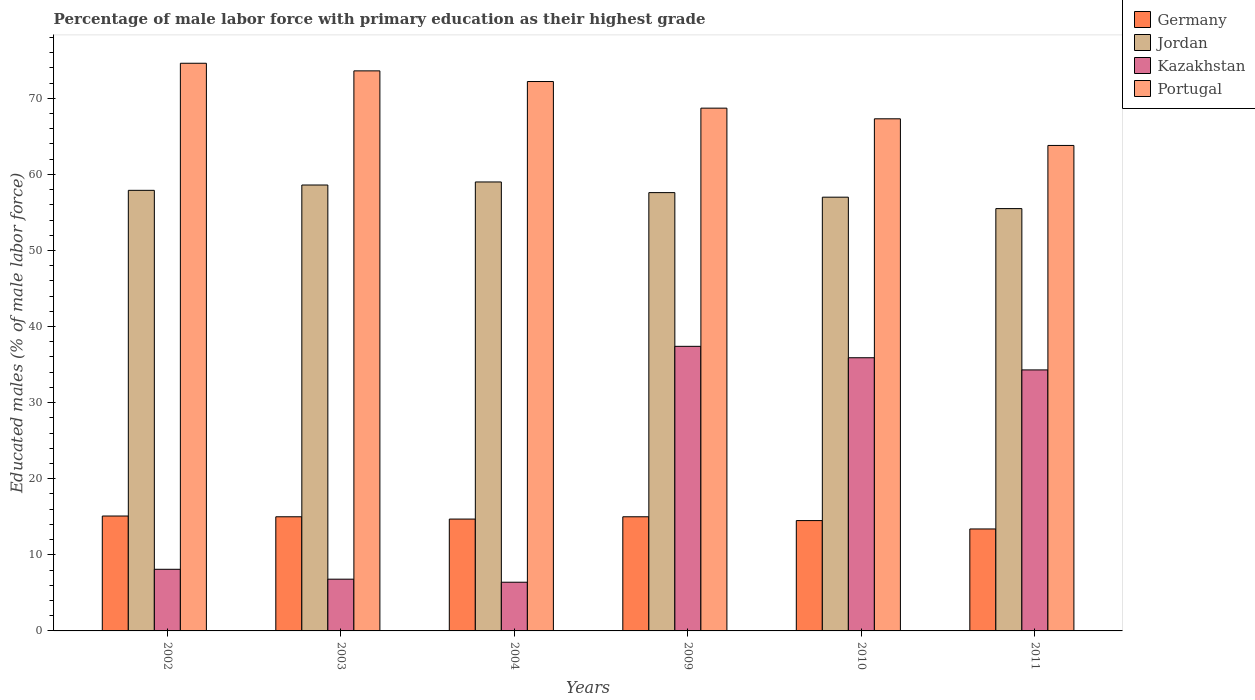How many different coloured bars are there?
Keep it short and to the point. 4. How many groups of bars are there?
Offer a very short reply. 6. Are the number of bars per tick equal to the number of legend labels?
Offer a very short reply. Yes. Are the number of bars on each tick of the X-axis equal?
Your answer should be compact. Yes. What is the label of the 5th group of bars from the left?
Provide a short and direct response. 2010. What is the percentage of male labor force with primary education in Germany in 2003?
Give a very brief answer. 15. Across all years, what is the maximum percentage of male labor force with primary education in Portugal?
Offer a very short reply. 74.6. Across all years, what is the minimum percentage of male labor force with primary education in Germany?
Provide a succinct answer. 13.4. In which year was the percentage of male labor force with primary education in Germany minimum?
Give a very brief answer. 2011. What is the total percentage of male labor force with primary education in Portugal in the graph?
Offer a very short reply. 420.2. What is the difference between the percentage of male labor force with primary education in Jordan in 2011 and the percentage of male labor force with primary education in Kazakhstan in 2009?
Offer a very short reply. 18.1. What is the average percentage of male labor force with primary education in Kazakhstan per year?
Provide a short and direct response. 21.48. In the year 2009, what is the difference between the percentage of male labor force with primary education in Jordan and percentage of male labor force with primary education in Portugal?
Keep it short and to the point. -11.1. In how many years, is the percentage of male labor force with primary education in Germany greater than 34 %?
Keep it short and to the point. 0. What is the ratio of the percentage of male labor force with primary education in Germany in 2003 to that in 2011?
Provide a succinct answer. 1.12. Is the percentage of male labor force with primary education in Jordan in 2003 less than that in 2009?
Provide a short and direct response. No. What is the difference between the highest and the second highest percentage of male labor force with primary education in Portugal?
Keep it short and to the point. 1. What is the difference between the highest and the lowest percentage of male labor force with primary education in Portugal?
Your answer should be compact. 10.8. In how many years, is the percentage of male labor force with primary education in Portugal greater than the average percentage of male labor force with primary education in Portugal taken over all years?
Offer a terse response. 3. What does the 2nd bar from the left in 2011 represents?
Offer a very short reply. Jordan. What does the 2nd bar from the right in 2009 represents?
Your response must be concise. Kazakhstan. Is it the case that in every year, the sum of the percentage of male labor force with primary education in Jordan and percentage of male labor force with primary education in Germany is greater than the percentage of male labor force with primary education in Kazakhstan?
Make the answer very short. Yes. How many bars are there?
Your response must be concise. 24. Are all the bars in the graph horizontal?
Provide a succinct answer. No. Does the graph contain grids?
Your response must be concise. No. How many legend labels are there?
Your response must be concise. 4. How are the legend labels stacked?
Your response must be concise. Vertical. What is the title of the graph?
Provide a succinct answer. Percentage of male labor force with primary education as their highest grade. Does "Mali" appear as one of the legend labels in the graph?
Offer a terse response. No. What is the label or title of the X-axis?
Ensure brevity in your answer.  Years. What is the label or title of the Y-axis?
Make the answer very short. Educated males (% of male labor force). What is the Educated males (% of male labor force) in Germany in 2002?
Keep it short and to the point. 15.1. What is the Educated males (% of male labor force) of Jordan in 2002?
Ensure brevity in your answer.  57.9. What is the Educated males (% of male labor force) of Kazakhstan in 2002?
Your response must be concise. 8.1. What is the Educated males (% of male labor force) in Portugal in 2002?
Your answer should be very brief. 74.6. What is the Educated males (% of male labor force) of Germany in 2003?
Make the answer very short. 15. What is the Educated males (% of male labor force) in Jordan in 2003?
Keep it short and to the point. 58.6. What is the Educated males (% of male labor force) in Kazakhstan in 2003?
Provide a short and direct response. 6.8. What is the Educated males (% of male labor force) of Portugal in 2003?
Your answer should be compact. 73.6. What is the Educated males (% of male labor force) in Germany in 2004?
Give a very brief answer. 14.7. What is the Educated males (% of male labor force) of Jordan in 2004?
Provide a succinct answer. 59. What is the Educated males (% of male labor force) in Kazakhstan in 2004?
Your answer should be compact. 6.4. What is the Educated males (% of male labor force) in Portugal in 2004?
Provide a succinct answer. 72.2. What is the Educated males (% of male labor force) of Germany in 2009?
Provide a succinct answer. 15. What is the Educated males (% of male labor force) in Jordan in 2009?
Ensure brevity in your answer.  57.6. What is the Educated males (% of male labor force) in Kazakhstan in 2009?
Make the answer very short. 37.4. What is the Educated males (% of male labor force) in Portugal in 2009?
Offer a very short reply. 68.7. What is the Educated males (% of male labor force) of Kazakhstan in 2010?
Provide a short and direct response. 35.9. What is the Educated males (% of male labor force) in Portugal in 2010?
Your answer should be very brief. 67.3. What is the Educated males (% of male labor force) of Germany in 2011?
Keep it short and to the point. 13.4. What is the Educated males (% of male labor force) of Jordan in 2011?
Provide a succinct answer. 55.5. What is the Educated males (% of male labor force) of Kazakhstan in 2011?
Your answer should be compact. 34.3. What is the Educated males (% of male labor force) in Portugal in 2011?
Offer a very short reply. 63.8. Across all years, what is the maximum Educated males (% of male labor force) in Germany?
Ensure brevity in your answer.  15.1. Across all years, what is the maximum Educated males (% of male labor force) in Jordan?
Your answer should be compact. 59. Across all years, what is the maximum Educated males (% of male labor force) in Kazakhstan?
Provide a succinct answer. 37.4. Across all years, what is the maximum Educated males (% of male labor force) of Portugal?
Your response must be concise. 74.6. Across all years, what is the minimum Educated males (% of male labor force) of Germany?
Provide a succinct answer. 13.4. Across all years, what is the minimum Educated males (% of male labor force) of Jordan?
Your answer should be compact. 55.5. Across all years, what is the minimum Educated males (% of male labor force) of Kazakhstan?
Provide a short and direct response. 6.4. Across all years, what is the minimum Educated males (% of male labor force) of Portugal?
Your response must be concise. 63.8. What is the total Educated males (% of male labor force) in Germany in the graph?
Offer a terse response. 87.7. What is the total Educated males (% of male labor force) in Jordan in the graph?
Make the answer very short. 345.6. What is the total Educated males (% of male labor force) of Kazakhstan in the graph?
Keep it short and to the point. 128.9. What is the total Educated males (% of male labor force) of Portugal in the graph?
Ensure brevity in your answer.  420.2. What is the difference between the Educated males (% of male labor force) in Portugal in 2002 and that in 2003?
Provide a succinct answer. 1. What is the difference between the Educated males (% of male labor force) of Germany in 2002 and that in 2004?
Your response must be concise. 0.4. What is the difference between the Educated males (% of male labor force) of Kazakhstan in 2002 and that in 2004?
Offer a very short reply. 1.7. What is the difference between the Educated males (% of male labor force) of Kazakhstan in 2002 and that in 2009?
Make the answer very short. -29.3. What is the difference between the Educated males (% of male labor force) in Portugal in 2002 and that in 2009?
Your answer should be very brief. 5.9. What is the difference between the Educated males (% of male labor force) in Jordan in 2002 and that in 2010?
Give a very brief answer. 0.9. What is the difference between the Educated males (% of male labor force) in Kazakhstan in 2002 and that in 2010?
Keep it short and to the point. -27.8. What is the difference between the Educated males (% of male labor force) in Portugal in 2002 and that in 2010?
Ensure brevity in your answer.  7.3. What is the difference between the Educated males (% of male labor force) of Germany in 2002 and that in 2011?
Your answer should be compact. 1.7. What is the difference between the Educated males (% of male labor force) of Kazakhstan in 2002 and that in 2011?
Provide a short and direct response. -26.2. What is the difference between the Educated males (% of male labor force) of Kazakhstan in 2003 and that in 2004?
Provide a succinct answer. 0.4. What is the difference between the Educated males (% of male labor force) in Jordan in 2003 and that in 2009?
Your answer should be compact. 1. What is the difference between the Educated males (% of male labor force) of Kazakhstan in 2003 and that in 2009?
Provide a succinct answer. -30.6. What is the difference between the Educated males (% of male labor force) in Portugal in 2003 and that in 2009?
Make the answer very short. 4.9. What is the difference between the Educated males (% of male labor force) in Jordan in 2003 and that in 2010?
Your answer should be compact. 1.6. What is the difference between the Educated males (% of male labor force) in Kazakhstan in 2003 and that in 2010?
Provide a short and direct response. -29.1. What is the difference between the Educated males (% of male labor force) of Portugal in 2003 and that in 2010?
Your response must be concise. 6.3. What is the difference between the Educated males (% of male labor force) of Jordan in 2003 and that in 2011?
Offer a terse response. 3.1. What is the difference between the Educated males (% of male labor force) in Kazakhstan in 2003 and that in 2011?
Keep it short and to the point. -27.5. What is the difference between the Educated males (% of male labor force) in Portugal in 2003 and that in 2011?
Your answer should be compact. 9.8. What is the difference between the Educated males (% of male labor force) of Germany in 2004 and that in 2009?
Provide a succinct answer. -0.3. What is the difference between the Educated males (% of male labor force) of Kazakhstan in 2004 and that in 2009?
Your answer should be compact. -31. What is the difference between the Educated males (% of male labor force) in Portugal in 2004 and that in 2009?
Ensure brevity in your answer.  3.5. What is the difference between the Educated males (% of male labor force) of Germany in 2004 and that in 2010?
Provide a short and direct response. 0.2. What is the difference between the Educated males (% of male labor force) in Kazakhstan in 2004 and that in 2010?
Provide a succinct answer. -29.5. What is the difference between the Educated males (% of male labor force) in Portugal in 2004 and that in 2010?
Ensure brevity in your answer.  4.9. What is the difference between the Educated males (% of male labor force) of Jordan in 2004 and that in 2011?
Offer a terse response. 3.5. What is the difference between the Educated males (% of male labor force) in Kazakhstan in 2004 and that in 2011?
Your answer should be compact. -27.9. What is the difference between the Educated males (% of male labor force) in Germany in 2009 and that in 2010?
Offer a terse response. 0.5. What is the difference between the Educated males (% of male labor force) in Jordan in 2009 and that in 2010?
Your answer should be very brief. 0.6. What is the difference between the Educated males (% of male labor force) of Germany in 2009 and that in 2011?
Provide a short and direct response. 1.6. What is the difference between the Educated males (% of male labor force) in Kazakhstan in 2009 and that in 2011?
Provide a short and direct response. 3.1. What is the difference between the Educated males (% of male labor force) of Germany in 2010 and that in 2011?
Give a very brief answer. 1.1. What is the difference between the Educated males (% of male labor force) of Jordan in 2010 and that in 2011?
Provide a short and direct response. 1.5. What is the difference between the Educated males (% of male labor force) in Germany in 2002 and the Educated males (% of male labor force) in Jordan in 2003?
Give a very brief answer. -43.5. What is the difference between the Educated males (% of male labor force) of Germany in 2002 and the Educated males (% of male labor force) of Portugal in 2003?
Offer a very short reply. -58.5. What is the difference between the Educated males (% of male labor force) in Jordan in 2002 and the Educated males (% of male labor force) in Kazakhstan in 2003?
Keep it short and to the point. 51.1. What is the difference between the Educated males (% of male labor force) in Jordan in 2002 and the Educated males (% of male labor force) in Portugal in 2003?
Provide a short and direct response. -15.7. What is the difference between the Educated males (% of male labor force) in Kazakhstan in 2002 and the Educated males (% of male labor force) in Portugal in 2003?
Ensure brevity in your answer.  -65.5. What is the difference between the Educated males (% of male labor force) of Germany in 2002 and the Educated males (% of male labor force) of Jordan in 2004?
Offer a very short reply. -43.9. What is the difference between the Educated males (% of male labor force) in Germany in 2002 and the Educated males (% of male labor force) in Kazakhstan in 2004?
Keep it short and to the point. 8.7. What is the difference between the Educated males (% of male labor force) in Germany in 2002 and the Educated males (% of male labor force) in Portugal in 2004?
Offer a terse response. -57.1. What is the difference between the Educated males (% of male labor force) of Jordan in 2002 and the Educated males (% of male labor force) of Kazakhstan in 2004?
Give a very brief answer. 51.5. What is the difference between the Educated males (% of male labor force) in Jordan in 2002 and the Educated males (% of male labor force) in Portugal in 2004?
Give a very brief answer. -14.3. What is the difference between the Educated males (% of male labor force) of Kazakhstan in 2002 and the Educated males (% of male labor force) of Portugal in 2004?
Offer a terse response. -64.1. What is the difference between the Educated males (% of male labor force) of Germany in 2002 and the Educated males (% of male labor force) of Jordan in 2009?
Your response must be concise. -42.5. What is the difference between the Educated males (% of male labor force) of Germany in 2002 and the Educated males (% of male labor force) of Kazakhstan in 2009?
Your response must be concise. -22.3. What is the difference between the Educated males (% of male labor force) of Germany in 2002 and the Educated males (% of male labor force) of Portugal in 2009?
Your response must be concise. -53.6. What is the difference between the Educated males (% of male labor force) in Kazakhstan in 2002 and the Educated males (% of male labor force) in Portugal in 2009?
Ensure brevity in your answer.  -60.6. What is the difference between the Educated males (% of male labor force) of Germany in 2002 and the Educated males (% of male labor force) of Jordan in 2010?
Offer a terse response. -41.9. What is the difference between the Educated males (% of male labor force) of Germany in 2002 and the Educated males (% of male labor force) of Kazakhstan in 2010?
Offer a terse response. -20.8. What is the difference between the Educated males (% of male labor force) in Germany in 2002 and the Educated males (% of male labor force) in Portugal in 2010?
Your answer should be very brief. -52.2. What is the difference between the Educated males (% of male labor force) of Jordan in 2002 and the Educated males (% of male labor force) of Kazakhstan in 2010?
Your answer should be compact. 22. What is the difference between the Educated males (% of male labor force) of Jordan in 2002 and the Educated males (% of male labor force) of Portugal in 2010?
Your answer should be very brief. -9.4. What is the difference between the Educated males (% of male labor force) in Kazakhstan in 2002 and the Educated males (% of male labor force) in Portugal in 2010?
Your response must be concise. -59.2. What is the difference between the Educated males (% of male labor force) of Germany in 2002 and the Educated males (% of male labor force) of Jordan in 2011?
Your answer should be very brief. -40.4. What is the difference between the Educated males (% of male labor force) of Germany in 2002 and the Educated males (% of male labor force) of Kazakhstan in 2011?
Your response must be concise. -19.2. What is the difference between the Educated males (% of male labor force) in Germany in 2002 and the Educated males (% of male labor force) in Portugal in 2011?
Your response must be concise. -48.7. What is the difference between the Educated males (% of male labor force) in Jordan in 2002 and the Educated males (% of male labor force) in Kazakhstan in 2011?
Offer a terse response. 23.6. What is the difference between the Educated males (% of male labor force) of Kazakhstan in 2002 and the Educated males (% of male labor force) of Portugal in 2011?
Offer a very short reply. -55.7. What is the difference between the Educated males (% of male labor force) of Germany in 2003 and the Educated males (% of male labor force) of Jordan in 2004?
Your answer should be compact. -44. What is the difference between the Educated males (% of male labor force) of Germany in 2003 and the Educated males (% of male labor force) of Kazakhstan in 2004?
Your response must be concise. 8.6. What is the difference between the Educated males (% of male labor force) of Germany in 2003 and the Educated males (% of male labor force) of Portugal in 2004?
Your answer should be very brief. -57.2. What is the difference between the Educated males (% of male labor force) in Jordan in 2003 and the Educated males (% of male labor force) in Kazakhstan in 2004?
Give a very brief answer. 52.2. What is the difference between the Educated males (% of male labor force) of Jordan in 2003 and the Educated males (% of male labor force) of Portugal in 2004?
Give a very brief answer. -13.6. What is the difference between the Educated males (% of male labor force) of Kazakhstan in 2003 and the Educated males (% of male labor force) of Portugal in 2004?
Offer a very short reply. -65.4. What is the difference between the Educated males (% of male labor force) of Germany in 2003 and the Educated males (% of male labor force) of Jordan in 2009?
Your response must be concise. -42.6. What is the difference between the Educated males (% of male labor force) of Germany in 2003 and the Educated males (% of male labor force) of Kazakhstan in 2009?
Your answer should be compact. -22.4. What is the difference between the Educated males (% of male labor force) of Germany in 2003 and the Educated males (% of male labor force) of Portugal in 2009?
Provide a short and direct response. -53.7. What is the difference between the Educated males (% of male labor force) in Jordan in 2003 and the Educated males (% of male labor force) in Kazakhstan in 2009?
Offer a very short reply. 21.2. What is the difference between the Educated males (% of male labor force) in Kazakhstan in 2003 and the Educated males (% of male labor force) in Portugal in 2009?
Give a very brief answer. -61.9. What is the difference between the Educated males (% of male labor force) in Germany in 2003 and the Educated males (% of male labor force) in Jordan in 2010?
Ensure brevity in your answer.  -42. What is the difference between the Educated males (% of male labor force) of Germany in 2003 and the Educated males (% of male labor force) of Kazakhstan in 2010?
Provide a succinct answer. -20.9. What is the difference between the Educated males (% of male labor force) of Germany in 2003 and the Educated males (% of male labor force) of Portugal in 2010?
Ensure brevity in your answer.  -52.3. What is the difference between the Educated males (% of male labor force) in Jordan in 2003 and the Educated males (% of male labor force) in Kazakhstan in 2010?
Ensure brevity in your answer.  22.7. What is the difference between the Educated males (% of male labor force) of Kazakhstan in 2003 and the Educated males (% of male labor force) of Portugal in 2010?
Your answer should be very brief. -60.5. What is the difference between the Educated males (% of male labor force) of Germany in 2003 and the Educated males (% of male labor force) of Jordan in 2011?
Provide a short and direct response. -40.5. What is the difference between the Educated males (% of male labor force) of Germany in 2003 and the Educated males (% of male labor force) of Kazakhstan in 2011?
Keep it short and to the point. -19.3. What is the difference between the Educated males (% of male labor force) of Germany in 2003 and the Educated males (% of male labor force) of Portugal in 2011?
Your answer should be compact. -48.8. What is the difference between the Educated males (% of male labor force) of Jordan in 2003 and the Educated males (% of male labor force) of Kazakhstan in 2011?
Keep it short and to the point. 24.3. What is the difference between the Educated males (% of male labor force) in Kazakhstan in 2003 and the Educated males (% of male labor force) in Portugal in 2011?
Provide a succinct answer. -57. What is the difference between the Educated males (% of male labor force) of Germany in 2004 and the Educated males (% of male labor force) of Jordan in 2009?
Provide a short and direct response. -42.9. What is the difference between the Educated males (% of male labor force) of Germany in 2004 and the Educated males (% of male labor force) of Kazakhstan in 2009?
Provide a short and direct response. -22.7. What is the difference between the Educated males (% of male labor force) in Germany in 2004 and the Educated males (% of male labor force) in Portugal in 2009?
Give a very brief answer. -54. What is the difference between the Educated males (% of male labor force) in Jordan in 2004 and the Educated males (% of male labor force) in Kazakhstan in 2009?
Provide a succinct answer. 21.6. What is the difference between the Educated males (% of male labor force) of Kazakhstan in 2004 and the Educated males (% of male labor force) of Portugal in 2009?
Provide a short and direct response. -62.3. What is the difference between the Educated males (% of male labor force) of Germany in 2004 and the Educated males (% of male labor force) of Jordan in 2010?
Offer a very short reply. -42.3. What is the difference between the Educated males (% of male labor force) in Germany in 2004 and the Educated males (% of male labor force) in Kazakhstan in 2010?
Make the answer very short. -21.2. What is the difference between the Educated males (% of male labor force) in Germany in 2004 and the Educated males (% of male labor force) in Portugal in 2010?
Give a very brief answer. -52.6. What is the difference between the Educated males (% of male labor force) in Jordan in 2004 and the Educated males (% of male labor force) in Kazakhstan in 2010?
Your answer should be very brief. 23.1. What is the difference between the Educated males (% of male labor force) of Kazakhstan in 2004 and the Educated males (% of male labor force) of Portugal in 2010?
Your answer should be very brief. -60.9. What is the difference between the Educated males (% of male labor force) in Germany in 2004 and the Educated males (% of male labor force) in Jordan in 2011?
Offer a very short reply. -40.8. What is the difference between the Educated males (% of male labor force) in Germany in 2004 and the Educated males (% of male labor force) in Kazakhstan in 2011?
Offer a terse response. -19.6. What is the difference between the Educated males (% of male labor force) in Germany in 2004 and the Educated males (% of male labor force) in Portugal in 2011?
Your answer should be compact. -49.1. What is the difference between the Educated males (% of male labor force) of Jordan in 2004 and the Educated males (% of male labor force) of Kazakhstan in 2011?
Give a very brief answer. 24.7. What is the difference between the Educated males (% of male labor force) of Jordan in 2004 and the Educated males (% of male labor force) of Portugal in 2011?
Your answer should be compact. -4.8. What is the difference between the Educated males (% of male labor force) of Kazakhstan in 2004 and the Educated males (% of male labor force) of Portugal in 2011?
Offer a very short reply. -57.4. What is the difference between the Educated males (% of male labor force) of Germany in 2009 and the Educated males (% of male labor force) of Jordan in 2010?
Your answer should be very brief. -42. What is the difference between the Educated males (% of male labor force) of Germany in 2009 and the Educated males (% of male labor force) of Kazakhstan in 2010?
Keep it short and to the point. -20.9. What is the difference between the Educated males (% of male labor force) of Germany in 2009 and the Educated males (% of male labor force) of Portugal in 2010?
Ensure brevity in your answer.  -52.3. What is the difference between the Educated males (% of male labor force) of Jordan in 2009 and the Educated males (% of male labor force) of Kazakhstan in 2010?
Give a very brief answer. 21.7. What is the difference between the Educated males (% of male labor force) of Jordan in 2009 and the Educated males (% of male labor force) of Portugal in 2010?
Give a very brief answer. -9.7. What is the difference between the Educated males (% of male labor force) of Kazakhstan in 2009 and the Educated males (% of male labor force) of Portugal in 2010?
Your answer should be compact. -29.9. What is the difference between the Educated males (% of male labor force) in Germany in 2009 and the Educated males (% of male labor force) in Jordan in 2011?
Keep it short and to the point. -40.5. What is the difference between the Educated males (% of male labor force) of Germany in 2009 and the Educated males (% of male labor force) of Kazakhstan in 2011?
Provide a short and direct response. -19.3. What is the difference between the Educated males (% of male labor force) in Germany in 2009 and the Educated males (% of male labor force) in Portugal in 2011?
Give a very brief answer. -48.8. What is the difference between the Educated males (% of male labor force) in Jordan in 2009 and the Educated males (% of male labor force) in Kazakhstan in 2011?
Provide a succinct answer. 23.3. What is the difference between the Educated males (% of male labor force) in Jordan in 2009 and the Educated males (% of male labor force) in Portugal in 2011?
Ensure brevity in your answer.  -6.2. What is the difference between the Educated males (% of male labor force) in Kazakhstan in 2009 and the Educated males (% of male labor force) in Portugal in 2011?
Make the answer very short. -26.4. What is the difference between the Educated males (% of male labor force) of Germany in 2010 and the Educated males (% of male labor force) of Jordan in 2011?
Your response must be concise. -41. What is the difference between the Educated males (% of male labor force) of Germany in 2010 and the Educated males (% of male labor force) of Kazakhstan in 2011?
Your answer should be compact. -19.8. What is the difference between the Educated males (% of male labor force) of Germany in 2010 and the Educated males (% of male labor force) of Portugal in 2011?
Keep it short and to the point. -49.3. What is the difference between the Educated males (% of male labor force) of Jordan in 2010 and the Educated males (% of male labor force) of Kazakhstan in 2011?
Your response must be concise. 22.7. What is the difference between the Educated males (% of male labor force) in Jordan in 2010 and the Educated males (% of male labor force) in Portugal in 2011?
Make the answer very short. -6.8. What is the difference between the Educated males (% of male labor force) of Kazakhstan in 2010 and the Educated males (% of male labor force) of Portugal in 2011?
Make the answer very short. -27.9. What is the average Educated males (% of male labor force) in Germany per year?
Give a very brief answer. 14.62. What is the average Educated males (% of male labor force) in Jordan per year?
Your response must be concise. 57.6. What is the average Educated males (% of male labor force) in Kazakhstan per year?
Provide a short and direct response. 21.48. What is the average Educated males (% of male labor force) in Portugal per year?
Keep it short and to the point. 70.03. In the year 2002, what is the difference between the Educated males (% of male labor force) of Germany and Educated males (% of male labor force) of Jordan?
Provide a succinct answer. -42.8. In the year 2002, what is the difference between the Educated males (% of male labor force) in Germany and Educated males (% of male labor force) in Portugal?
Ensure brevity in your answer.  -59.5. In the year 2002, what is the difference between the Educated males (% of male labor force) in Jordan and Educated males (% of male labor force) in Kazakhstan?
Make the answer very short. 49.8. In the year 2002, what is the difference between the Educated males (% of male labor force) of Jordan and Educated males (% of male labor force) of Portugal?
Provide a short and direct response. -16.7. In the year 2002, what is the difference between the Educated males (% of male labor force) of Kazakhstan and Educated males (% of male labor force) of Portugal?
Ensure brevity in your answer.  -66.5. In the year 2003, what is the difference between the Educated males (% of male labor force) in Germany and Educated males (% of male labor force) in Jordan?
Your response must be concise. -43.6. In the year 2003, what is the difference between the Educated males (% of male labor force) of Germany and Educated males (% of male labor force) of Portugal?
Provide a short and direct response. -58.6. In the year 2003, what is the difference between the Educated males (% of male labor force) of Jordan and Educated males (% of male labor force) of Kazakhstan?
Your answer should be very brief. 51.8. In the year 2003, what is the difference between the Educated males (% of male labor force) in Jordan and Educated males (% of male labor force) in Portugal?
Provide a succinct answer. -15. In the year 2003, what is the difference between the Educated males (% of male labor force) of Kazakhstan and Educated males (% of male labor force) of Portugal?
Your response must be concise. -66.8. In the year 2004, what is the difference between the Educated males (% of male labor force) of Germany and Educated males (% of male labor force) of Jordan?
Give a very brief answer. -44.3. In the year 2004, what is the difference between the Educated males (% of male labor force) in Germany and Educated males (% of male labor force) in Kazakhstan?
Offer a terse response. 8.3. In the year 2004, what is the difference between the Educated males (% of male labor force) of Germany and Educated males (% of male labor force) of Portugal?
Your answer should be compact. -57.5. In the year 2004, what is the difference between the Educated males (% of male labor force) in Jordan and Educated males (% of male labor force) in Kazakhstan?
Make the answer very short. 52.6. In the year 2004, what is the difference between the Educated males (% of male labor force) of Kazakhstan and Educated males (% of male labor force) of Portugal?
Ensure brevity in your answer.  -65.8. In the year 2009, what is the difference between the Educated males (% of male labor force) of Germany and Educated males (% of male labor force) of Jordan?
Ensure brevity in your answer.  -42.6. In the year 2009, what is the difference between the Educated males (% of male labor force) of Germany and Educated males (% of male labor force) of Kazakhstan?
Your answer should be compact. -22.4. In the year 2009, what is the difference between the Educated males (% of male labor force) in Germany and Educated males (% of male labor force) in Portugal?
Make the answer very short. -53.7. In the year 2009, what is the difference between the Educated males (% of male labor force) of Jordan and Educated males (% of male labor force) of Kazakhstan?
Keep it short and to the point. 20.2. In the year 2009, what is the difference between the Educated males (% of male labor force) in Kazakhstan and Educated males (% of male labor force) in Portugal?
Provide a short and direct response. -31.3. In the year 2010, what is the difference between the Educated males (% of male labor force) in Germany and Educated males (% of male labor force) in Jordan?
Ensure brevity in your answer.  -42.5. In the year 2010, what is the difference between the Educated males (% of male labor force) in Germany and Educated males (% of male labor force) in Kazakhstan?
Offer a very short reply. -21.4. In the year 2010, what is the difference between the Educated males (% of male labor force) in Germany and Educated males (% of male labor force) in Portugal?
Give a very brief answer. -52.8. In the year 2010, what is the difference between the Educated males (% of male labor force) of Jordan and Educated males (% of male labor force) of Kazakhstan?
Ensure brevity in your answer.  21.1. In the year 2010, what is the difference between the Educated males (% of male labor force) in Jordan and Educated males (% of male labor force) in Portugal?
Provide a short and direct response. -10.3. In the year 2010, what is the difference between the Educated males (% of male labor force) of Kazakhstan and Educated males (% of male labor force) of Portugal?
Your answer should be compact. -31.4. In the year 2011, what is the difference between the Educated males (% of male labor force) in Germany and Educated males (% of male labor force) in Jordan?
Provide a succinct answer. -42.1. In the year 2011, what is the difference between the Educated males (% of male labor force) in Germany and Educated males (% of male labor force) in Kazakhstan?
Offer a very short reply. -20.9. In the year 2011, what is the difference between the Educated males (% of male labor force) of Germany and Educated males (% of male labor force) of Portugal?
Offer a terse response. -50.4. In the year 2011, what is the difference between the Educated males (% of male labor force) of Jordan and Educated males (% of male labor force) of Kazakhstan?
Offer a very short reply. 21.2. In the year 2011, what is the difference between the Educated males (% of male labor force) of Jordan and Educated males (% of male labor force) of Portugal?
Offer a very short reply. -8.3. In the year 2011, what is the difference between the Educated males (% of male labor force) in Kazakhstan and Educated males (% of male labor force) in Portugal?
Give a very brief answer. -29.5. What is the ratio of the Educated males (% of male labor force) in Germany in 2002 to that in 2003?
Provide a succinct answer. 1.01. What is the ratio of the Educated males (% of male labor force) of Jordan in 2002 to that in 2003?
Offer a terse response. 0.99. What is the ratio of the Educated males (% of male labor force) of Kazakhstan in 2002 to that in 2003?
Your answer should be compact. 1.19. What is the ratio of the Educated males (% of male labor force) of Portugal in 2002 to that in 2003?
Make the answer very short. 1.01. What is the ratio of the Educated males (% of male labor force) of Germany in 2002 to that in 2004?
Your answer should be compact. 1.03. What is the ratio of the Educated males (% of male labor force) of Jordan in 2002 to that in 2004?
Provide a succinct answer. 0.98. What is the ratio of the Educated males (% of male labor force) in Kazakhstan in 2002 to that in 2004?
Make the answer very short. 1.27. What is the ratio of the Educated males (% of male labor force) of Portugal in 2002 to that in 2004?
Your response must be concise. 1.03. What is the ratio of the Educated males (% of male labor force) in Jordan in 2002 to that in 2009?
Ensure brevity in your answer.  1.01. What is the ratio of the Educated males (% of male labor force) in Kazakhstan in 2002 to that in 2009?
Provide a short and direct response. 0.22. What is the ratio of the Educated males (% of male labor force) in Portugal in 2002 to that in 2009?
Provide a succinct answer. 1.09. What is the ratio of the Educated males (% of male labor force) in Germany in 2002 to that in 2010?
Provide a succinct answer. 1.04. What is the ratio of the Educated males (% of male labor force) in Jordan in 2002 to that in 2010?
Keep it short and to the point. 1.02. What is the ratio of the Educated males (% of male labor force) in Kazakhstan in 2002 to that in 2010?
Provide a short and direct response. 0.23. What is the ratio of the Educated males (% of male labor force) of Portugal in 2002 to that in 2010?
Your response must be concise. 1.11. What is the ratio of the Educated males (% of male labor force) of Germany in 2002 to that in 2011?
Make the answer very short. 1.13. What is the ratio of the Educated males (% of male labor force) in Jordan in 2002 to that in 2011?
Offer a very short reply. 1.04. What is the ratio of the Educated males (% of male labor force) in Kazakhstan in 2002 to that in 2011?
Provide a succinct answer. 0.24. What is the ratio of the Educated males (% of male labor force) in Portugal in 2002 to that in 2011?
Your answer should be compact. 1.17. What is the ratio of the Educated males (% of male labor force) of Germany in 2003 to that in 2004?
Your answer should be very brief. 1.02. What is the ratio of the Educated males (% of male labor force) in Portugal in 2003 to that in 2004?
Ensure brevity in your answer.  1.02. What is the ratio of the Educated males (% of male labor force) in Germany in 2003 to that in 2009?
Offer a very short reply. 1. What is the ratio of the Educated males (% of male labor force) of Jordan in 2003 to that in 2009?
Make the answer very short. 1.02. What is the ratio of the Educated males (% of male labor force) of Kazakhstan in 2003 to that in 2009?
Keep it short and to the point. 0.18. What is the ratio of the Educated males (% of male labor force) in Portugal in 2003 to that in 2009?
Offer a very short reply. 1.07. What is the ratio of the Educated males (% of male labor force) of Germany in 2003 to that in 2010?
Offer a very short reply. 1.03. What is the ratio of the Educated males (% of male labor force) of Jordan in 2003 to that in 2010?
Ensure brevity in your answer.  1.03. What is the ratio of the Educated males (% of male labor force) of Kazakhstan in 2003 to that in 2010?
Give a very brief answer. 0.19. What is the ratio of the Educated males (% of male labor force) in Portugal in 2003 to that in 2010?
Ensure brevity in your answer.  1.09. What is the ratio of the Educated males (% of male labor force) of Germany in 2003 to that in 2011?
Give a very brief answer. 1.12. What is the ratio of the Educated males (% of male labor force) in Jordan in 2003 to that in 2011?
Offer a very short reply. 1.06. What is the ratio of the Educated males (% of male labor force) of Kazakhstan in 2003 to that in 2011?
Give a very brief answer. 0.2. What is the ratio of the Educated males (% of male labor force) of Portugal in 2003 to that in 2011?
Make the answer very short. 1.15. What is the ratio of the Educated males (% of male labor force) of Jordan in 2004 to that in 2009?
Provide a short and direct response. 1.02. What is the ratio of the Educated males (% of male labor force) in Kazakhstan in 2004 to that in 2009?
Give a very brief answer. 0.17. What is the ratio of the Educated males (% of male labor force) in Portugal in 2004 to that in 2009?
Keep it short and to the point. 1.05. What is the ratio of the Educated males (% of male labor force) in Germany in 2004 to that in 2010?
Provide a succinct answer. 1.01. What is the ratio of the Educated males (% of male labor force) in Jordan in 2004 to that in 2010?
Ensure brevity in your answer.  1.04. What is the ratio of the Educated males (% of male labor force) in Kazakhstan in 2004 to that in 2010?
Provide a short and direct response. 0.18. What is the ratio of the Educated males (% of male labor force) of Portugal in 2004 to that in 2010?
Your response must be concise. 1.07. What is the ratio of the Educated males (% of male labor force) of Germany in 2004 to that in 2011?
Keep it short and to the point. 1.1. What is the ratio of the Educated males (% of male labor force) of Jordan in 2004 to that in 2011?
Keep it short and to the point. 1.06. What is the ratio of the Educated males (% of male labor force) in Kazakhstan in 2004 to that in 2011?
Keep it short and to the point. 0.19. What is the ratio of the Educated males (% of male labor force) of Portugal in 2004 to that in 2011?
Your response must be concise. 1.13. What is the ratio of the Educated males (% of male labor force) of Germany in 2009 to that in 2010?
Offer a terse response. 1.03. What is the ratio of the Educated males (% of male labor force) in Jordan in 2009 to that in 2010?
Offer a very short reply. 1.01. What is the ratio of the Educated males (% of male labor force) in Kazakhstan in 2009 to that in 2010?
Provide a succinct answer. 1.04. What is the ratio of the Educated males (% of male labor force) of Portugal in 2009 to that in 2010?
Make the answer very short. 1.02. What is the ratio of the Educated males (% of male labor force) in Germany in 2009 to that in 2011?
Provide a succinct answer. 1.12. What is the ratio of the Educated males (% of male labor force) of Jordan in 2009 to that in 2011?
Make the answer very short. 1.04. What is the ratio of the Educated males (% of male labor force) of Kazakhstan in 2009 to that in 2011?
Give a very brief answer. 1.09. What is the ratio of the Educated males (% of male labor force) of Portugal in 2009 to that in 2011?
Make the answer very short. 1.08. What is the ratio of the Educated males (% of male labor force) of Germany in 2010 to that in 2011?
Your response must be concise. 1.08. What is the ratio of the Educated males (% of male labor force) in Jordan in 2010 to that in 2011?
Offer a terse response. 1.03. What is the ratio of the Educated males (% of male labor force) of Kazakhstan in 2010 to that in 2011?
Your answer should be compact. 1.05. What is the ratio of the Educated males (% of male labor force) in Portugal in 2010 to that in 2011?
Keep it short and to the point. 1.05. What is the difference between the highest and the second highest Educated males (% of male labor force) in Germany?
Make the answer very short. 0.1. What is the difference between the highest and the second highest Educated males (% of male labor force) in Kazakhstan?
Offer a very short reply. 1.5. What is the difference between the highest and the lowest Educated males (% of male labor force) in Germany?
Offer a very short reply. 1.7. What is the difference between the highest and the lowest Educated males (% of male labor force) of Kazakhstan?
Give a very brief answer. 31. 